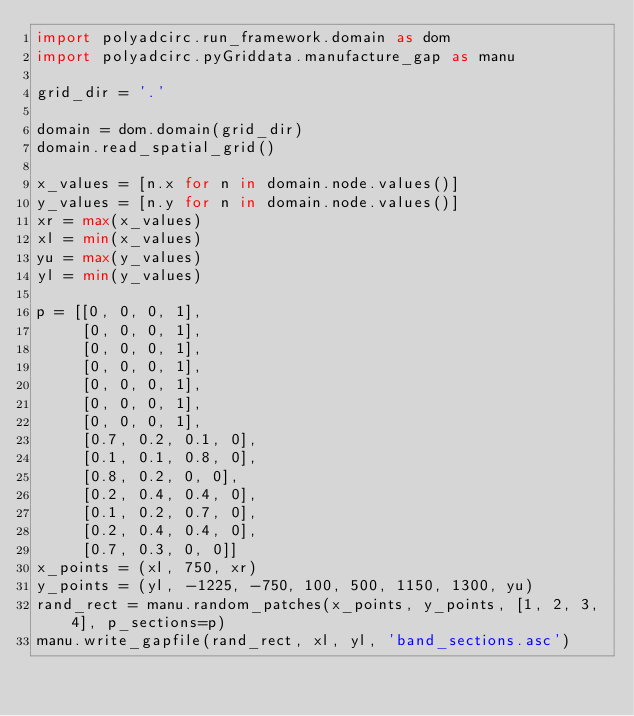Convert code to text. <code><loc_0><loc_0><loc_500><loc_500><_Python_>import polyadcirc.run_framework.domain as dom
import polyadcirc.pyGriddata.manufacture_gap as manu

grid_dir = '.'

domain = dom.domain(grid_dir)
domain.read_spatial_grid()

x_values = [n.x for n in domain.node.values()]
y_values = [n.y for n in domain.node.values()]
xr = max(x_values)
xl = min(x_values)
yu = max(y_values)
yl = min(y_values)

p = [[0, 0, 0, 1],
     [0, 0, 0, 1],
     [0, 0, 0, 1],
     [0, 0, 0, 1],
     [0, 0, 0, 1],
     [0, 0, 0, 1],
     [0, 0, 0, 1],
     [0.7, 0.2, 0.1, 0],
     [0.1, 0.1, 0.8, 0],
     [0.8, 0.2, 0, 0],
     [0.2, 0.4, 0.4, 0],
     [0.1, 0.2, 0.7, 0],
     [0.2, 0.4, 0.4, 0],
     [0.7, 0.3, 0, 0]]
x_points = (xl, 750, xr)
y_points = (yl, -1225, -750, 100, 500, 1150, 1300, yu)
rand_rect = manu.random_patches(x_points, y_points, [1, 2, 3, 4], p_sections=p)
manu.write_gapfile(rand_rect, xl, yl, 'band_sections.asc')

</code> 